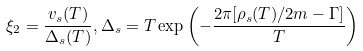<formula> <loc_0><loc_0><loc_500><loc_500>\xi _ { 2 } = \frac { v _ { s } ( T ) } { \Delta _ { s } ( T ) } , \Delta _ { s } = T \exp \left ( - \frac { 2 \pi [ \rho _ { s } ( T ) / 2 m - \Gamma ] } { T } \right )</formula> 